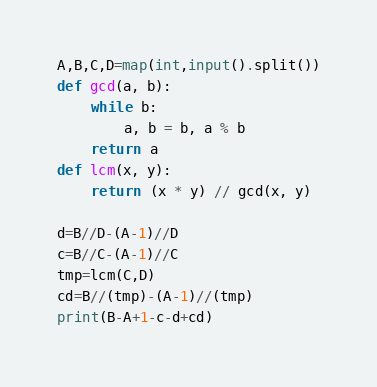<code> <loc_0><loc_0><loc_500><loc_500><_Python_>A,B,C,D=map(int,input().split())
def gcd(a, b):
    while b:
        a, b = b, a % b
    return a
def lcm(x, y):
    return (x * y) // gcd(x, y)
  
d=B//D-(A-1)//D
c=B//C-(A-1)//C
tmp=lcm(C,D)
cd=B//(tmp)-(A-1)//(tmp)
print(B-A+1-c-d+cd)</code> 